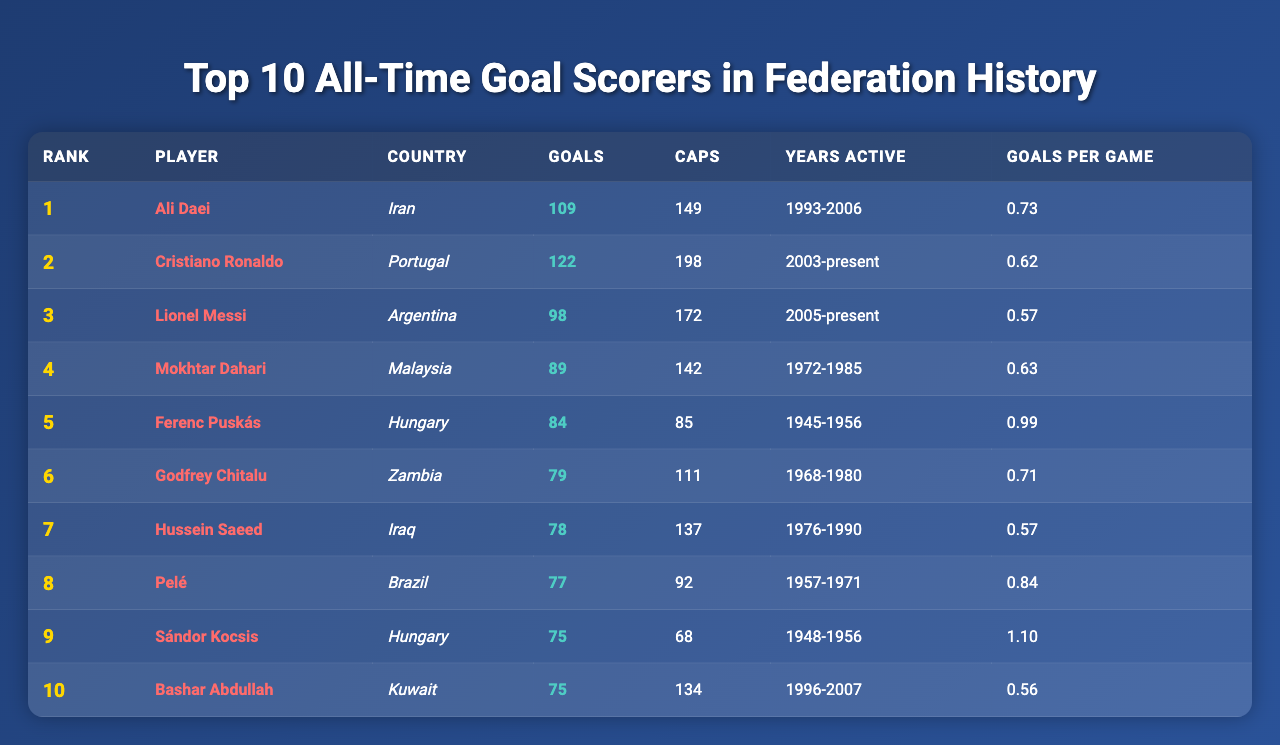What is the total number of goals scored by the top 10 players? To find the total number of goals scored by these players, we need to sum the goals for each player: 109 + 122 + 98 + 89 + 84 + 79 + 78 + 77 + 75 + 75 = 1006.
Answer: 1006 Who has the highest goals per game ratio? Looking at the 'Goals per Game' column, we see that Sándor Kocsis has the highest ratio with 1.10 goals per game compared to the others.
Answer: Sándor Kocsis How many players scored more than 80 goals? By checking the 'Goals' column, we see that Ali Daei (109), Cristiano Ronaldo (122), Mokhtar Dahari (89), Ferenc Puskás (84), and Godfrey Chitalu (79) scored more than 80 goals. This accounts for 4 players.
Answer: 4 Is it true that Pelé scored more goals than Lionel Messi? By referring to the goals scored, Pelé has 77 goals while Messi has 98 goals, so Messi scored more than Pelé. Therefore, the statement is false.
Answer: False What is the average number of caps for the top 10 players? To calculate the average caps, we sum the caps: 149 + 198 + 172 + 142 + 85 + 111 + 137 + 92 + 68 + 134 = 1148. Then, we divide by the number of players (10): 1148 / 10 = 114.8.
Answer: 114.8 Which player has the longest active playing years? By looking at the 'Years Active' column, we note the duration for each: Ali Daei (13 years), Cristiano Ronaldo (20+), Lionel Messi (18+), Mokhtar Dahari (13), and Ferenc Puskás (11). Cristiano Ronaldo is still active, so he has the longest duration.
Answer: Cristiano Ronaldo How many players scored less than 80 goals? In the 'Goals' column, players with fewer than 80 goals are: Godfrey Chitalu (79), Hussein Saeed (78), Pelé (77), Sándor Kocsis (75), and Bashar Abdullah (75). This accounts for 5 players.
Answer: 5 Which country has a player on the list with the most goals scored? The player from Portugal, Cristiano Ronaldo, has the highest goal count of 122 goals, making Portugal the country represented with the most goals.
Answer: Portugal If you combine the goals of players from Hungary, how many total goals do they have? Players from Hungary are Ferenc Puskás with 84 goals and Sándor Kocsis with 75 goals. Summing these gives us 84 + 75 = 159 goals.
Answer: 159 Which player has the lowest goals per game ratio among the top 10? By reviewing the 'Goals per Game' column, Bashar Abdullah has the lowest ratio at 0.56 compared to the others.
Answer: Bashar Abdullah 